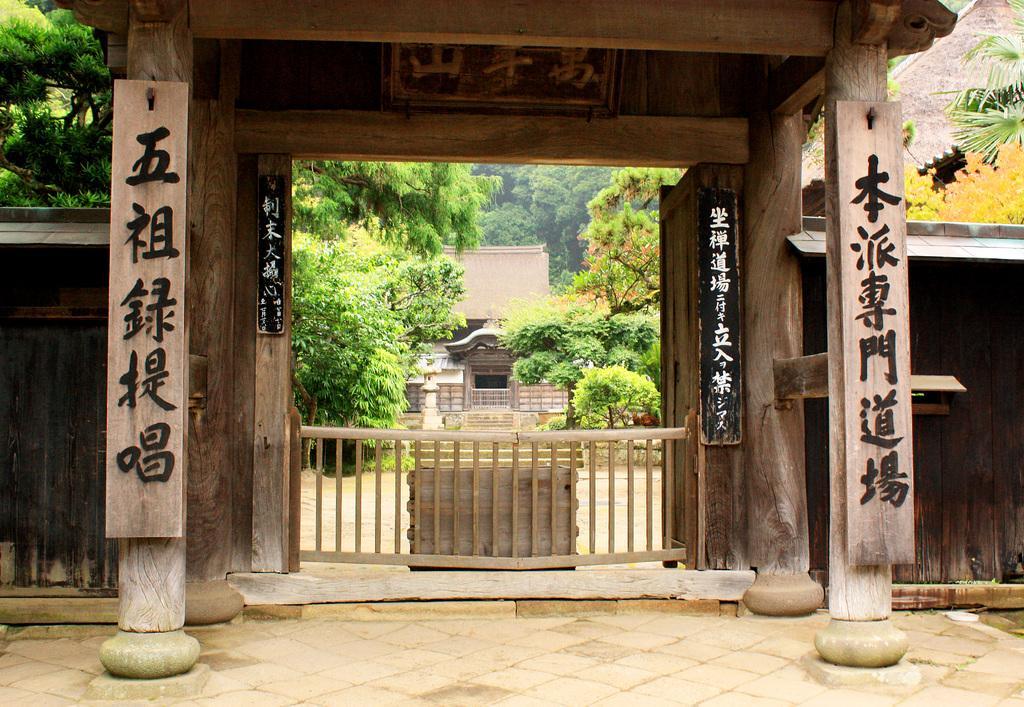In one or two sentences, can you explain what this image depicts? This is an entrance. In this there are wooden pillars. On the pillars something is written. Also there is fencing. On the sides there are wooden walls. In the background there are trees and a building. 